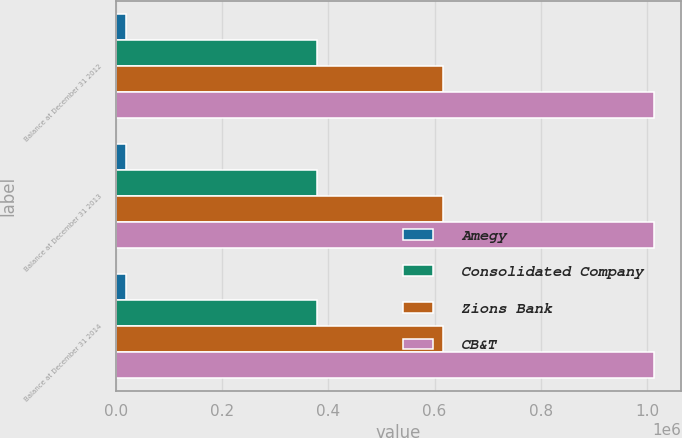Convert chart to OTSL. <chart><loc_0><loc_0><loc_500><loc_500><stacked_bar_chart><ecel><fcel>Balance at December 31 2012<fcel>Balance at December 31 2013<fcel>Balance at December 31 2014<nl><fcel>Amegy<fcel>19514<fcel>19514<fcel>19514<nl><fcel>Consolidated Company<fcel>379024<fcel>379024<fcel>379024<nl><fcel>Zions Bank<fcel>615591<fcel>615591<fcel>615591<nl><fcel>CB&T<fcel>1.01413e+06<fcel>1.01413e+06<fcel>1.01413e+06<nl></chart> 